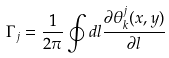Convert formula to latex. <formula><loc_0><loc_0><loc_500><loc_500>\Gamma _ { j } = \frac { 1 } { 2 \pi } \oint d { l } \frac { \partial \theta ^ { j } _ { k } ( x , y ) } { \partial { l } }</formula> 